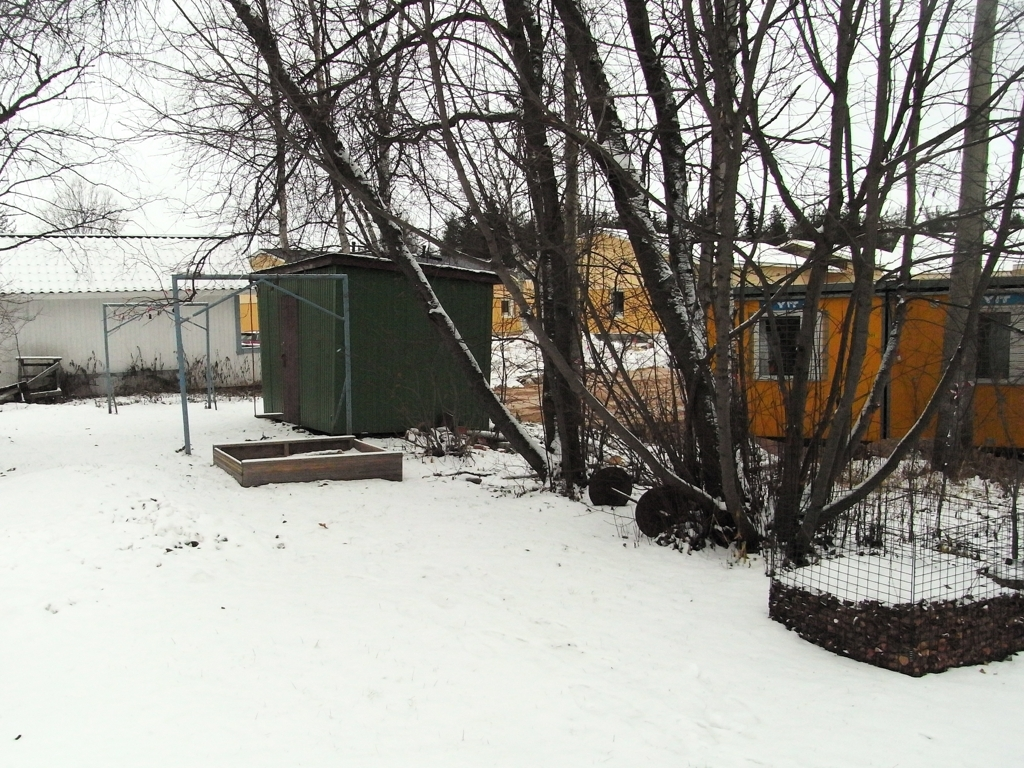Can you describe the weather or season depicted in this image? The image shows a layer of snow covering the ground, indicating that it's winter or in a seasonal transition where snowfall is present. The sky appears overcast, suggesting it could be a cold and cloudy day. 